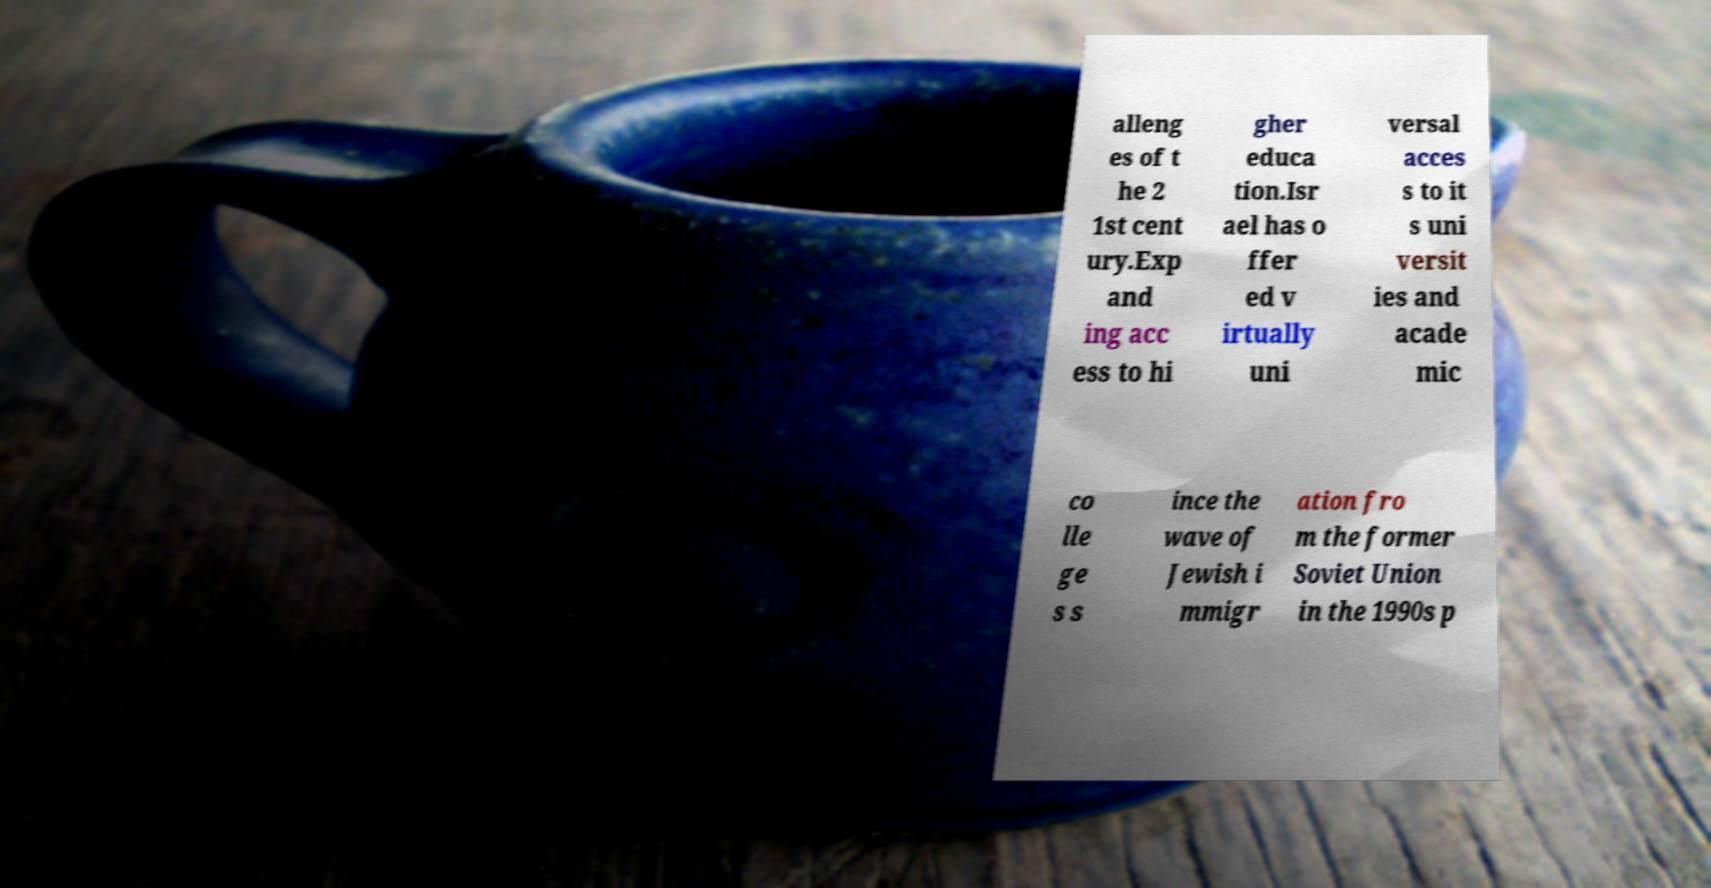Can you read and provide the text displayed in the image?This photo seems to have some interesting text. Can you extract and type it out for me? alleng es of t he 2 1st cent ury.Exp and ing acc ess to hi gher educa tion.Isr ael has o ffer ed v irtually uni versal acces s to it s uni versit ies and acade mic co lle ge s s ince the wave of Jewish i mmigr ation fro m the former Soviet Union in the 1990s p 